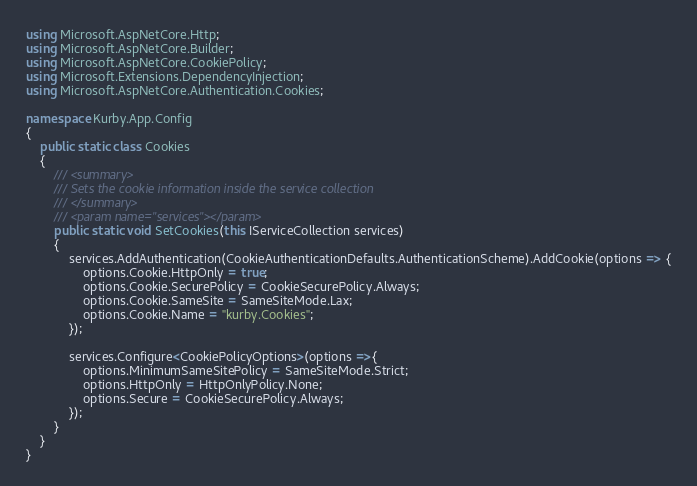Convert code to text. <code><loc_0><loc_0><loc_500><loc_500><_C#_>using Microsoft.AspNetCore.Http;
using Microsoft.AspNetCore.Builder;
using Microsoft.AspNetCore.CookiePolicy;
using Microsoft.Extensions.DependencyInjection;
using Microsoft.AspNetCore.Authentication.Cookies;

namespace Kurby.App.Config
{
    public static class Cookies
    {
        /// <summary>
        /// Sets the cookie information inside the service collection
        /// </summary>
        /// <param name="services"></param>
        public static void SetCookies(this IServiceCollection services)
        {
            services.AddAuthentication(CookieAuthenticationDefaults.AuthenticationScheme).AddCookie(options => {
                options.Cookie.HttpOnly = true;
                options.Cookie.SecurePolicy = CookieSecurePolicy.Always;
                options.Cookie.SameSite = SameSiteMode.Lax;
                options.Cookie.Name = "kurby.Cookies";
            });

            services.Configure<CookiePolicyOptions>(options =>{
                options.MinimumSameSitePolicy = SameSiteMode.Strict;
                options.HttpOnly = HttpOnlyPolicy.None;
                options.Secure = CookieSecurePolicy.Always;
            });
        }
    }
}</code> 